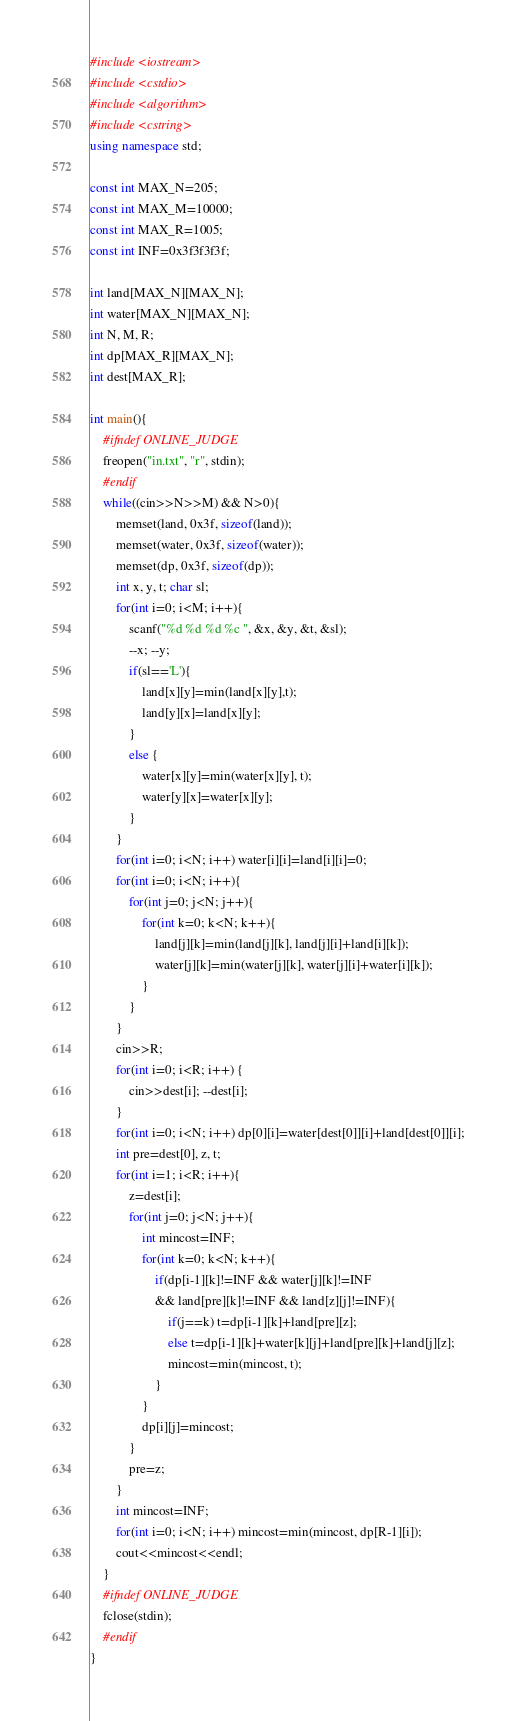<code> <loc_0><loc_0><loc_500><loc_500><_C++_>#include <iostream>
#include <cstdio>
#include <algorithm>
#include <cstring>
using namespace std;

const int MAX_N=205;
const int MAX_M=10000;
const int MAX_R=1005;
const int INF=0x3f3f3f3f;

int land[MAX_N][MAX_N];
int water[MAX_N][MAX_N];
int N, M, R;
int dp[MAX_R][MAX_N];
int dest[MAX_R];

int main(){
    #ifndef ONLINE_JUDGE
    freopen("in.txt", "r", stdin);
    #endif
    while((cin>>N>>M) && N>0){
        memset(land, 0x3f, sizeof(land));
        memset(water, 0x3f, sizeof(water));
        memset(dp, 0x3f, sizeof(dp));
        int x, y, t; char sl;
        for(int i=0; i<M; i++){
            scanf("%d %d %d %c ", &x, &y, &t, &sl);
            --x; --y;
            if(sl=='L'){
				land[x][y]=min(land[x][y],t);
				land[y][x]=land[x][y];
			}
            else {
				water[x][y]=min(water[x][y], t);
				water[y][x]=water[x][y];
			}
        }
        for(int i=0; i<N; i++) water[i][i]=land[i][i]=0;
        for(int i=0; i<N; i++){
        	for(int j=0; j<N; j++){
            	for(int k=0; k<N; k++){
                	land[j][k]=min(land[j][k], land[j][i]+land[i][k]);
                	water[j][k]=min(water[j][k], water[j][i]+water[i][k]);
            	}
        	}
   	    }
        cin>>R;
        for(int i=0; i<R; i++) {
			cin>>dest[i]; --dest[i];
		}
        for(int i=0; i<N; i++) dp[0][i]=water[dest[0]][i]+land[dest[0]][i];
        int pre=dest[0], z, t;
        for(int i=1; i<R; i++){
            z=dest[i]; 
            for(int j=0; j<N; j++){
                int mincost=INF;
                for(int k=0; k<N; k++){
                    if(dp[i-1][k]!=INF && water[j][k]!=INF 
                    && land[pre][k]!=INF && land[z][j]!=INF){
                        if(j==k) t=dp[i-1][k]+land[pre][z];
                        else t=dp[i-1][k]+water[k][j]+land[pre][k]+land[j][z];
                        mincost=min(mincost, t);
                    }
                }
                dp[i][j]=mincost;
            }
            pre=z;
        }
        int mincost=INF;
        for(int i=0; i<N; i++) mincost=min(mincost, dp[R-1][i]);
        cout<<mincost<<endl;
    }
    #ifndef ONLINE_JUDGE
    fclose(stdin);
    #endif
}
</code> 